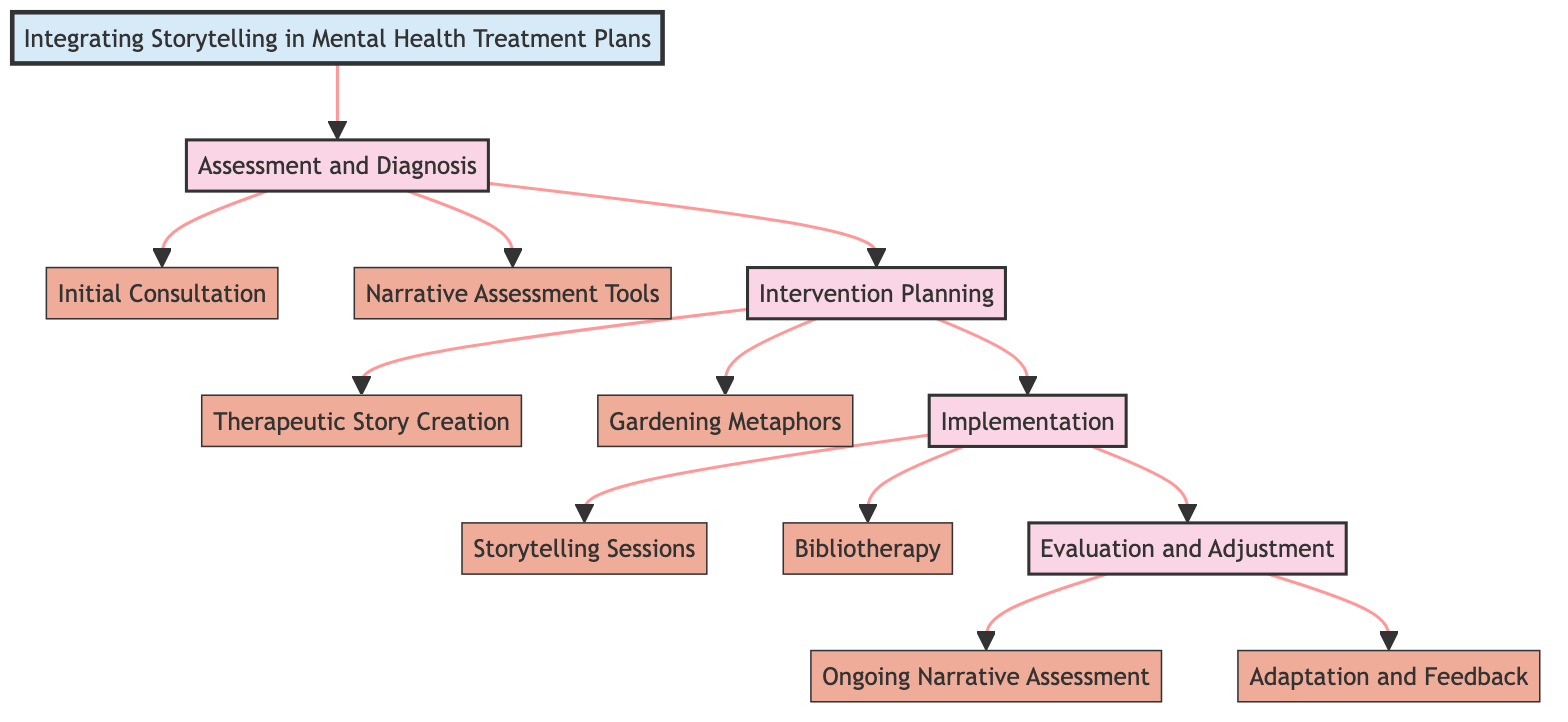What is the first stage in the pathway? The diagram lists "Assessment and Diagnosis" as the first stage among the other stages, indicating the starting point of the clinical pathway.
Answer: Assessment and Diagnosis How many key elements are in the "Implementation" stage? There are two key elements listed under the "Implementation" stage: "Storytelling Sessions" and "Bibliotherapy". Therefore, the total is counted as two elements.
Answer: 2 What element focuses on using personal stories to address challenges? The key element named "Therapeutic Story Creation" specifically involves collaborating with the patient to craft personal stories that address mental health challenges.
Answer: Therapeutic Story Creation Which stage includes "Ongoing Narrative Assessment"? The stage "Evaluation and Adjustment" includes the key element "Ongoing Narrative Assessment" that focuses on continually assessing the patient's progress.
Answer: Evaluation and Adjustment What is the purpose of "Bibliotherapy"? "Bibliotherapy" is described as recommending specific literature, such as mystery novels, that align with treatment goals to promote reflection and discussion.
Answer: Promote reflection and discussion How does "Gardening Metaphors" contribute to mental health? The key element "Gardening Metaphors" utilizes gardening analogies to symbolize personal growth and resilience, helping patients visualize their progress.
Answer: Symbolize personal growth and resilience What is the relationship between "Assessment and Diagnosis" and "Intervention Planning"? "Assessment and Diagnosis" directly leads to "Intervention Planning", as upon completing the assessment, the next logical step is to plan interventions based on the findings.
Answer: Directly leads to Which element deals with adapting treatment plans? "Adaptation and Feedback" is the key element concerned with adjusting treatment plans based on patient feedback and narrative evolution during therapy sessions.
Answer: Adaptation and Feedback What narrative technique is used to understand trauma? The element named "Narrative Assessment Tools" employs techniques like the Storytelling Method and Narrative Exposure Therapy to gain insights about trauma and stressors.
Answer: Narrative Assessment Tools 